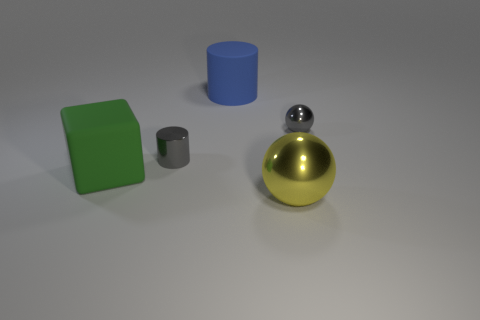What color is the big metallic object?
Offer a very short reply. Yellow. What number of gray metal things are to the left of the tiny gray metal object in front of the small gray metal ball?
Make the answer very short. 0. Does the yellow object have the same size as the ball behind the big sphere?
Offer a terse response. No. Is the green cube the same size as the gray cylinder?
Provide a short and direct response. No. Are there any green matte cubes that have the same size as the gray metallic sphere?
Keep it short and to the point. No. What is the material of the sphere in front of the green object?
Give a very brief answer. Metal. What is the color of the cylinder that is the same material as the green cube?
Your answer should be compact. Blue. How many shiny objects are either small objects or big blue objects?
Keep it short and to the point. 2. The yellow metallic thing that is the same size as the green matte block is what shape?
Your response must be concise. Sphere. How many things are either things that are behind the large green matte object or gray objects that are to the right of the blue thing?
Keep it short and to the point. 3. 